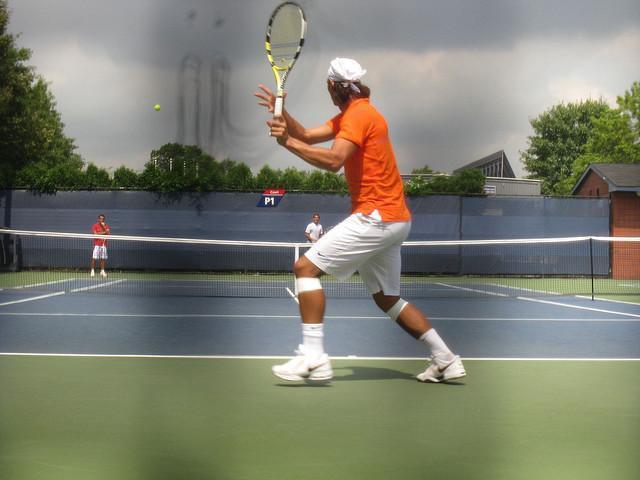How many knee braces is the closest player wearing?
Give a very brief answer. 2. 